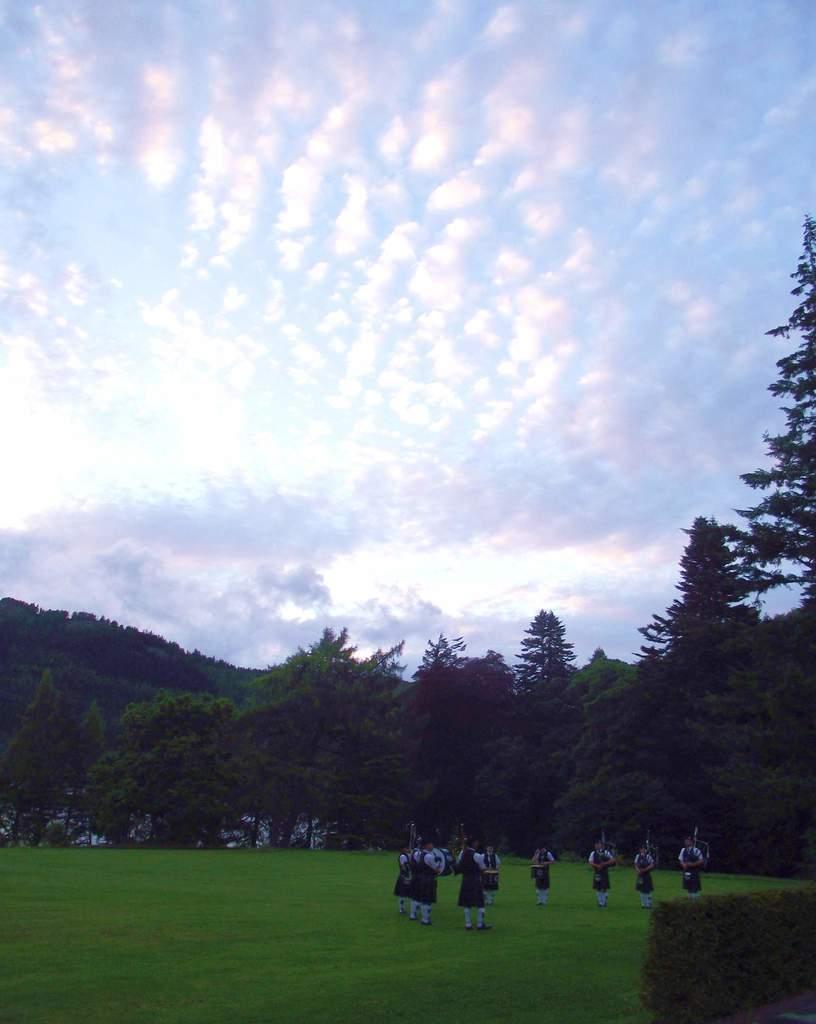Describe this image in one or two sentences. At the bottom there are few persons standing on the ground and playing musical instruments and on the right there are plants. In the background we can see trees,objects which are not clear and clouds in the sky. 